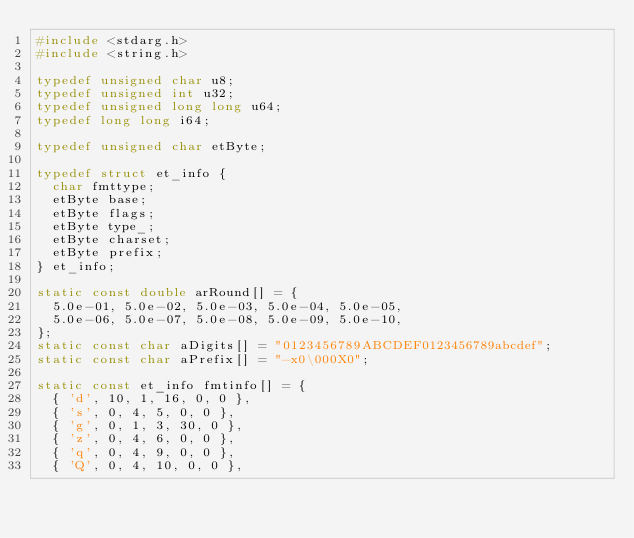<code> <loc_0><loc_0><loc_500><loc_500><_C_>#include <stdarg.h>
#include <string.h>

typedef unsigned char u8;
typedef unsigned int u32;
typedef unsigned long long u64;
typedef long long i64;

typedef unsigned char etByte;

typedef struct et_info {
  char fmttype;
  etByte base;
  etByte flags;
  etByte type_;
  etByte charset;
  etByte prefix;
} et_info;

static const double arRound[] = {
  5.0e-01, 5.0e-02, 5.0e-03, 5.0e-04, 5.0e-05,
  5.0e-06, 5.0e-07, 5.0e-08, 5.0e-09, 5.0e-10,
};
static const char aDigits[] = "0123456789ABCDEF0123456789abcdef";
static const char aPrefix[] = "-x0\000X0";

static const et_info fmtinfo[] = {
  { 'd', 10, 1, 16, 0, 0 },
  { 's', 0, 4, 5, 0, 0 },
  { 'g', 0, 1, 3, 30, 0 },
  { 'z', 0, 4, 6, 0, 0 },
  { 'q', 0, 4, 9, 0, 0 },
  { 'Q', 0, 4, 10, 0, 0 },</code> 